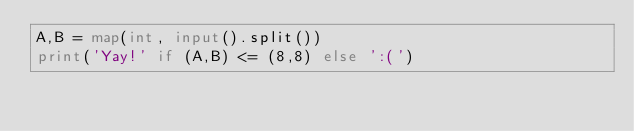<code> <loc_0><loc_0><loc_500><loc_500><_Python_>A,B = map(int, input().split())
print('Yay!' if (A,B) <= (8,8) else ':(')</code> 